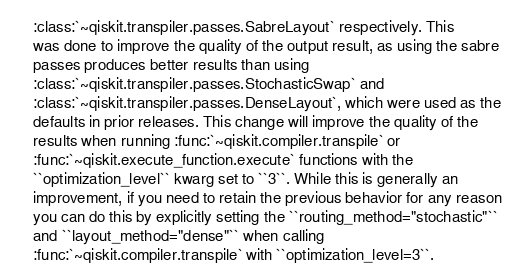Convert code to text. <code><loc_0><loc_0><loc_500><loc_500><_YAML_>    :class:`~qiskit.transpiler.passes.SabreLayout` respectively. This
    was done to improve the quality of the output result, as using the sabre
    passes produces better results than using
    :class:`~qiskit.transpiler.passes.StochasticSwap` and
    :class:`~qiskit.transpiler.passes.DenseLayout`, which were used as the
    defaults in prior releases. This change will improve the quality of the
    results when running :func:`~qiskit.compiler.transpile` or
    :func:`~qiskit.execute_function.execute` functions with the
    ``optimization_level`` kwarg set to ``3``. While this is generally an
    improvement, if you need to retain the previous behavior for any reason
    you can do this by explicitly setting the ``routing_method="stochastic"``
    and ``layout_method="dense"`` when calling
    :func:`~qiskit.compiler.transpile` with ``optimization_level=3``.
</code> 